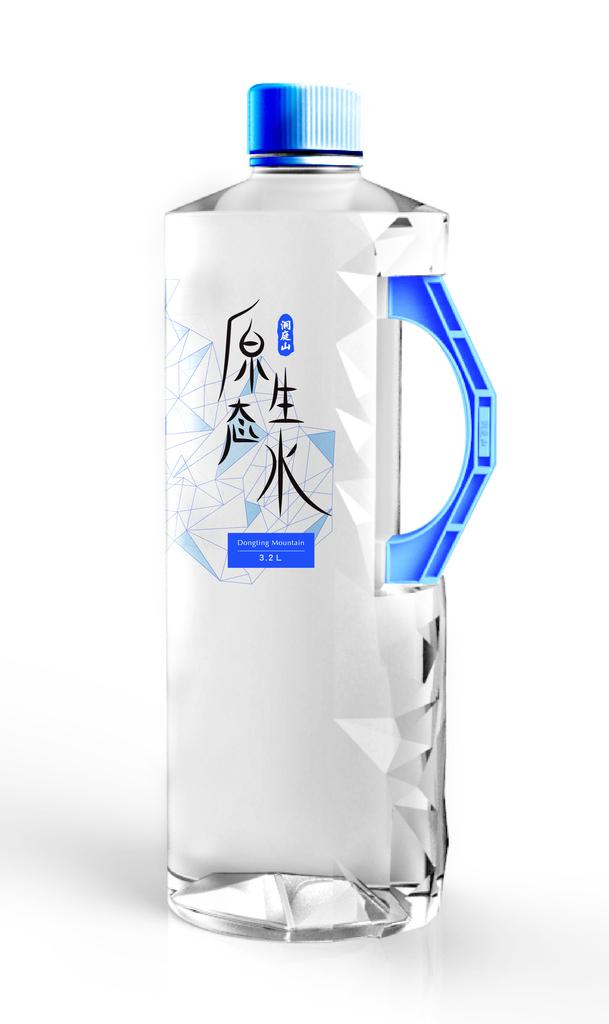What is the main object in the image? The main object in the image is a water bottle. What type of disgusting behavior is the dog exhibiting with the water bottle in the image? There is no dog present in the image, and the water bottle is not involved in any disgusting behavior. 